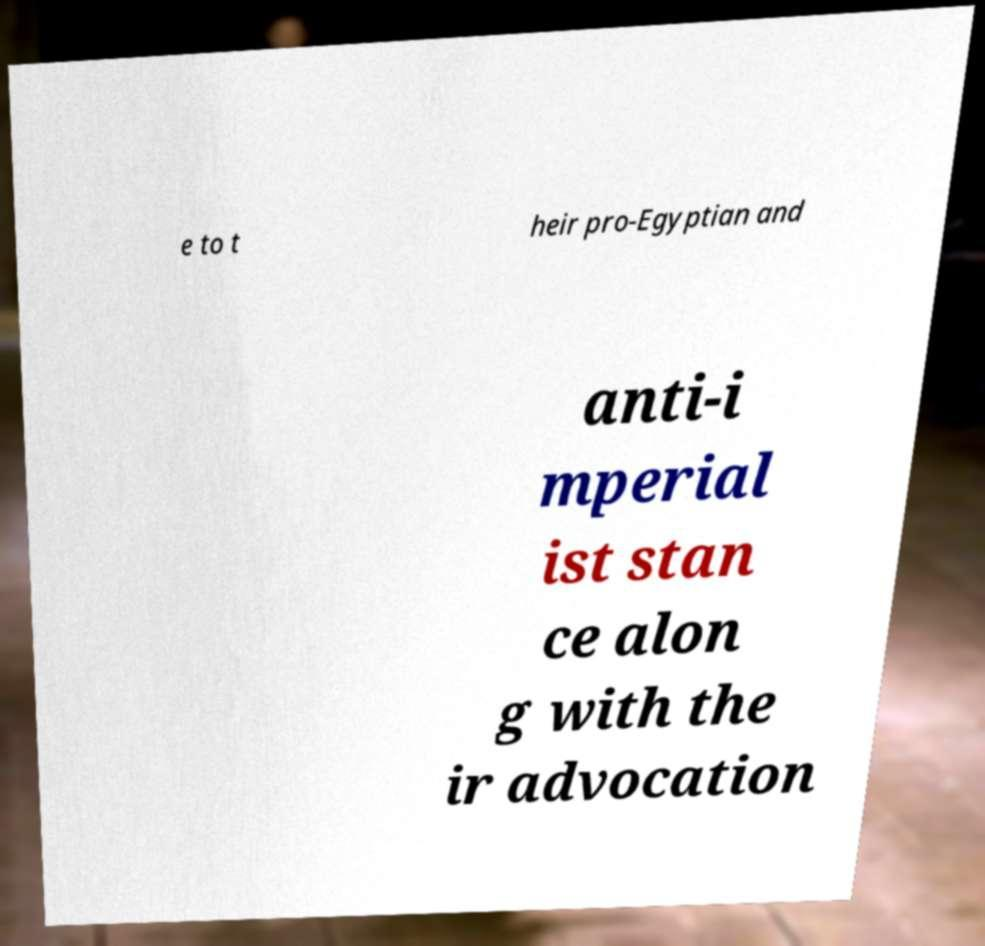Can you read and provide the text displayed in the image?This photo seems to have some interesting text. Can you extract and type it out for me? e to t heir pro-Egyptian and anti-i mperial ist stan ce alon g with the ir advocation 